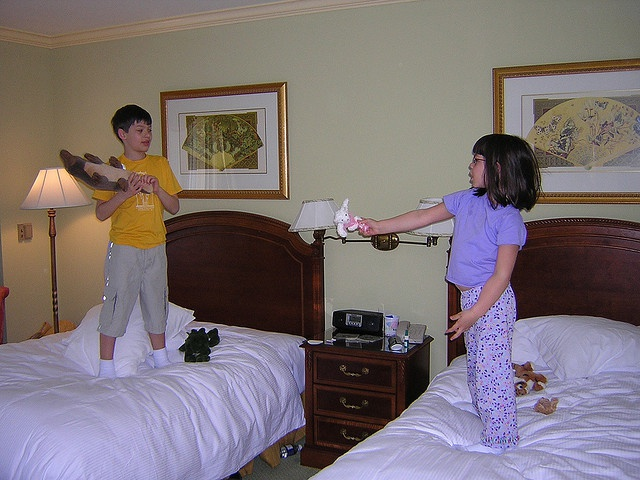Describe the objects in this image and their specific colors. I can see bed in gray, darkgray, and black tones, bed in gray, darkgray, and black tones, people in gray, violet, and black tones, people in gray and olive tones, and clock in gray and black tones in this image. 